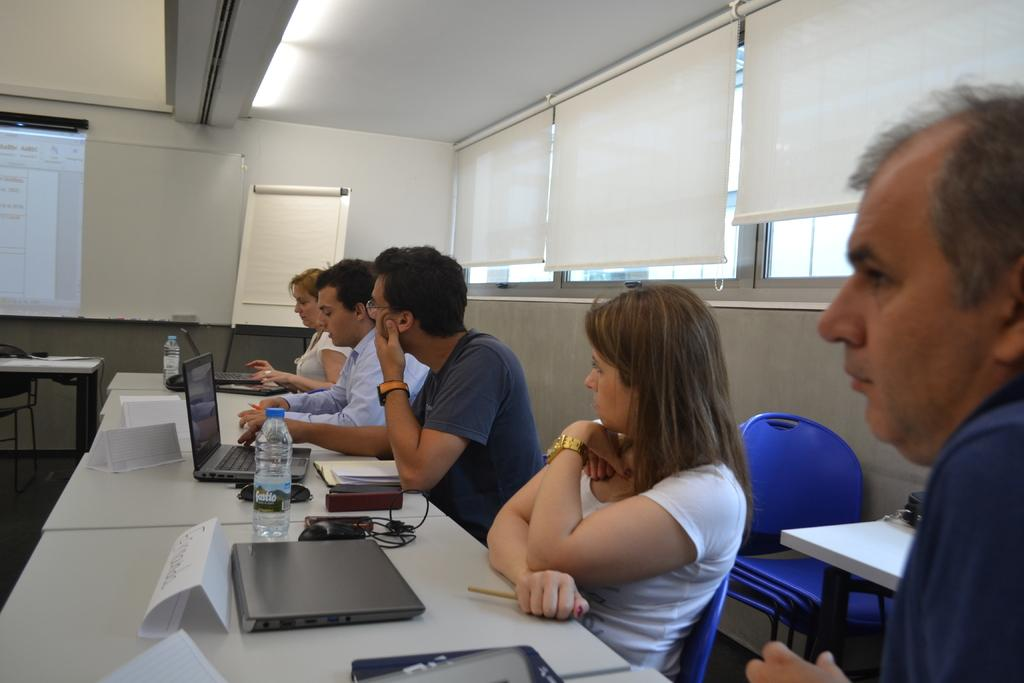How many people are in the image? There is a group of people in the image. What are the people doing in the image? The people are sitting in chairs. Where are the chairs located in relation to the table? The chairs are near a table. What items can be seen on the table? There is a name paper, a laptop, a bottle, and a book on the table. What can be seen in the background of the image? There is a screen, a table, and a board in the background. What type of bells can be heard ringing in the image? There are no bells present in the image, and therefore no sound can be heard. What message of peace is being conveyed by the people in the image? The image does not convey any specific message of peace; it simply shows a group of people sitting near a table. 